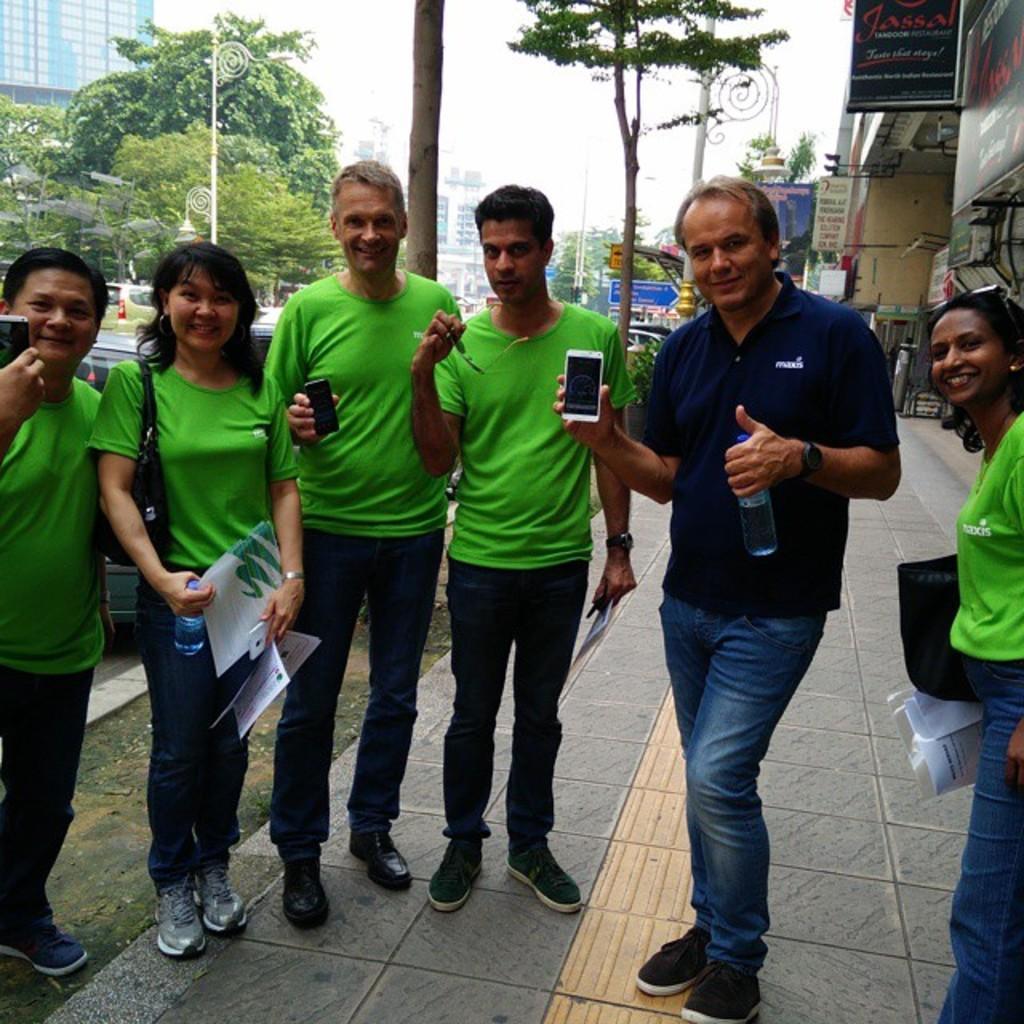In one or two sentences, can you explain what this image depicts? In this picture there are people standing and smiling, among them there are three men holding mobiles. We can see boards, trees, poles and lights. In the background of the image we can see buildings and sky. 